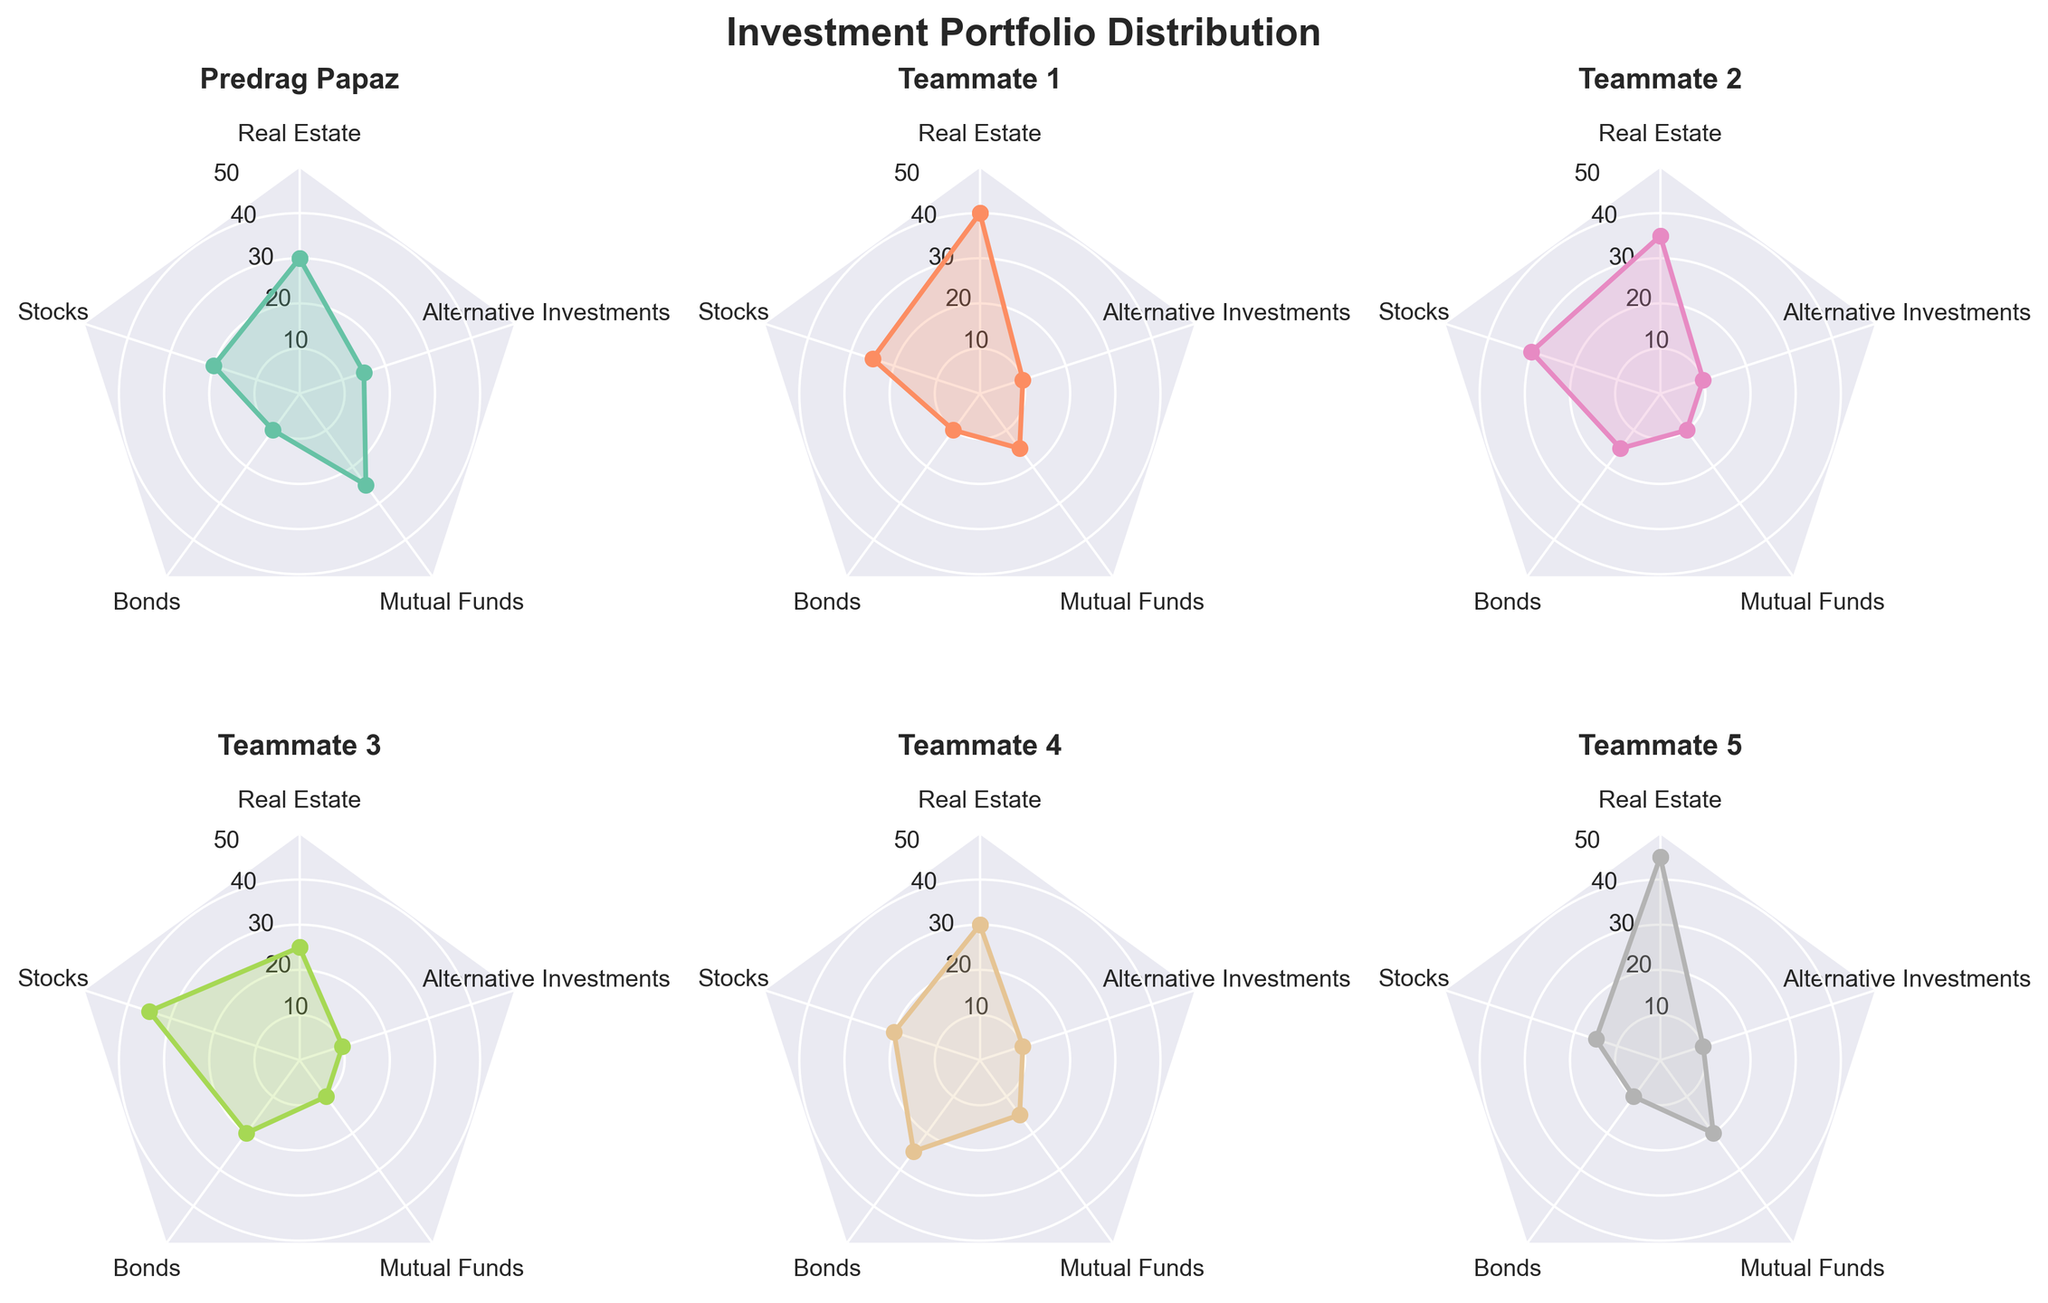What is the distribution of Predrag Papaz's portfolio? By looking at the radar chart subplot labeled "Predrag Papaz", we can see the values for each investment category: Real Estate (30), Stocks (20), Bonds (10), Mutual Funds (25), and Alternative Investments (15).
Answer: Real Estate (30), Stocks (20), Bonds (10), Mutual Funds (25), Alternative Investments (15) Which teammate has the highest allocation in Real Estate? By comparing the Real Estate values across the subplots, Teammate 5 has the highest allocation with 45%.
Answer: Teammate 5 How does Teammate 3's stock investment compare to the other teammates? Teammate 3 has a stock investment of 35%, which is higher than Predrag Papaz (20%), Teammate 1 (25%), Teammate 2 (30%), Teammate 4 (20%), and Teammate 5 (15%). Teammate 3 has the highest stock investment among all.
Answer: Teammate 3 has the highest stock investment What are the two highest allocations in Teammate 4's portfolio? Looking at Teammate 4's radar chart, the highest allocations are in Bonds (25%) and Real Estate (30%).
Answer: Bonds (25%) and Real Estate (30%) What is the average allocation for Bonds across all individuals? Sum the Bond values for all individuals: 10 (Predrag Papaz) + 10 (Teammate 1) + 15 (Teammate 2) + 20 (Teammate 3) + 25 (Teammate 4) + 10 (Teammate 5) = 90. The average is 90 / 6 = 15.
Answer: 15 Which investment category has the smallest range in allocation among all individuals? The ranges for each category are: Real Estate (45 - 25 = 20), Stocks (35 - 15 = 20), Bonds (25 - 10 = 15), Mutual Funds (25 - 10 = 15), and Alternative Investments (15 - 10 = 5). Alternative Investments has the smallest range of 5%.
Answer: Alternative Investments What is the sum of allocations in alternative investments across all teammates? Sum the Alternative Investments values: 15 (Predrag Papaz) + 10 (Teammate 1) + 10 (Teammate 2) + 10 (Teammate 3) + 10 (Teammate 4) + 10 (Teammate 5) = 65.
Answer: 65 Which teammate has the most balanced portfolio (smallest difference between highest and lowest allocation)? Calculate the range (highest - lowest) for each teammate: Predrag Papaz (30-10=20), Teammate 1 (40-10=30), Teammate 2 (35-10=25), Teammate 3 (35-10=25), Teammate 4 (30-10=20), Teammate 5 (45-10=35). Both Predrag Papaz and Teammate 4 have the smallest range of 20.
Answer: Predrag Papaz and Teammate 4 Which teammate has the lowest allocation in Mutual Funds? By comparing the Mutual Funds values, the lowest allocation is by Teammate 3 with 10%.
Answer: Teammate 3 What is the total percentage allocation in real estate for all individuals combined? Sum the Real Estate values: 30 (Predrag Papaz) + 40 (Teammate 1) + 35 (Teammate 2) + 25 (Teammate 3) + 30 (Teammate 4) + 45 (Teammate 5) = 205.
Answer: 205 